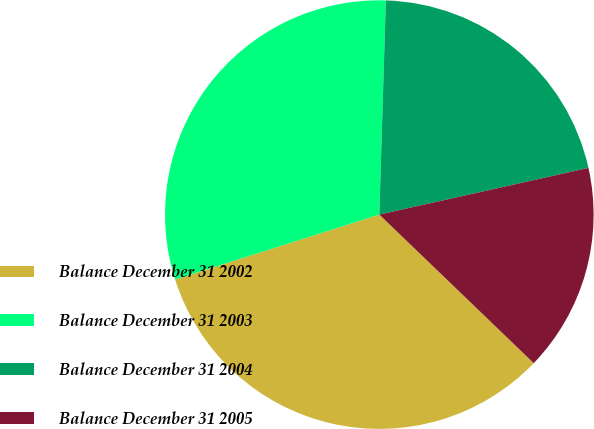Convert chart. <chart><loc_0><loc_0><loc_500><loc_500><pie_chart><fcel>Balance December 31 2002<fcel>Balance December 31 2003<fcel>Balance December 31 2004<fcel>Balance December 31 2005<nl><fcel>32.91%<fcel>30.38%<fcel>21.02%<fcel>15.69%<nl></chart> 